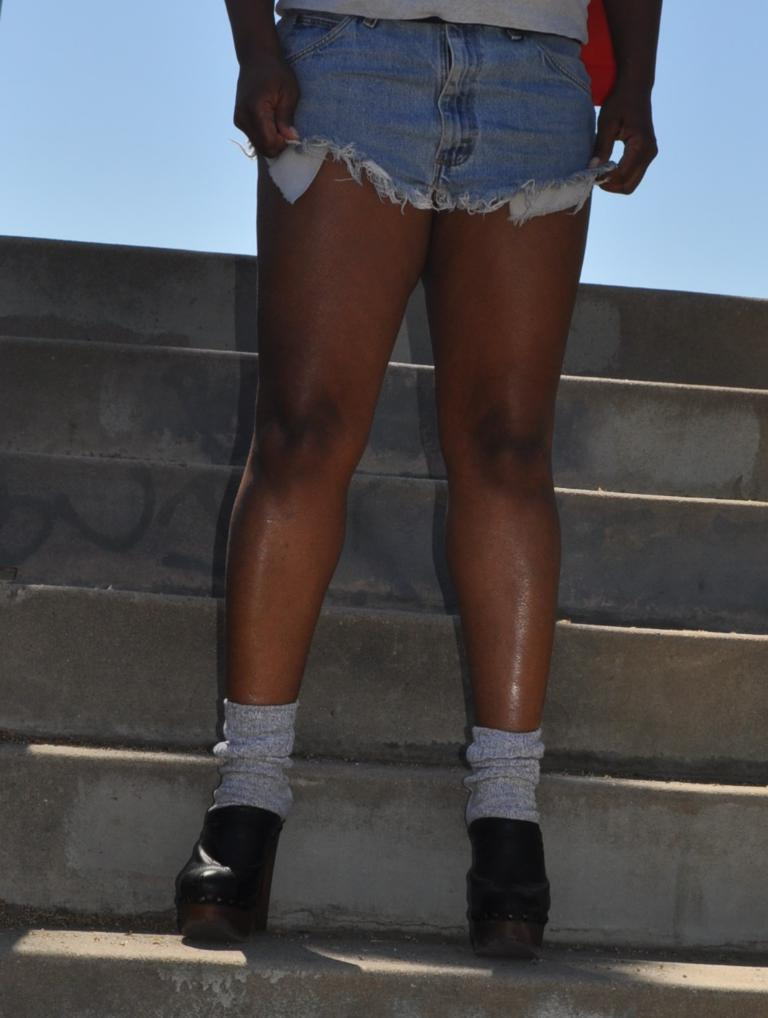What is the main subject of the image? There is a person in the image. What type of clothing is the person wearing? The person is wearing shorts and shoes. Where is the person located in the image? The person is standing on a staircase. What type of voice does the person have in the image? There is no information about the person's voice in the image. How many brothers does the person have in the image? There is no information about the person's family in the image. 